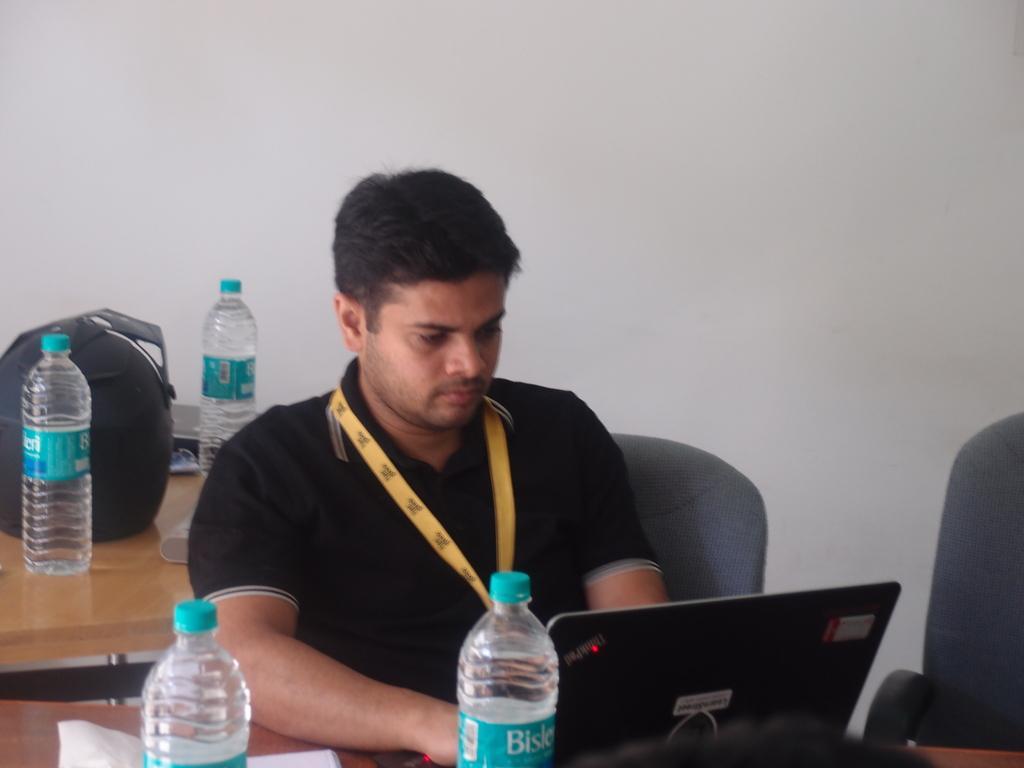Please provide a concise description of this image. In the middle, man is sitting on the chair and staring towards laptop ,i think he is doing some work. To the left there is a table on that table there is a bottle ,bag and some other items. 